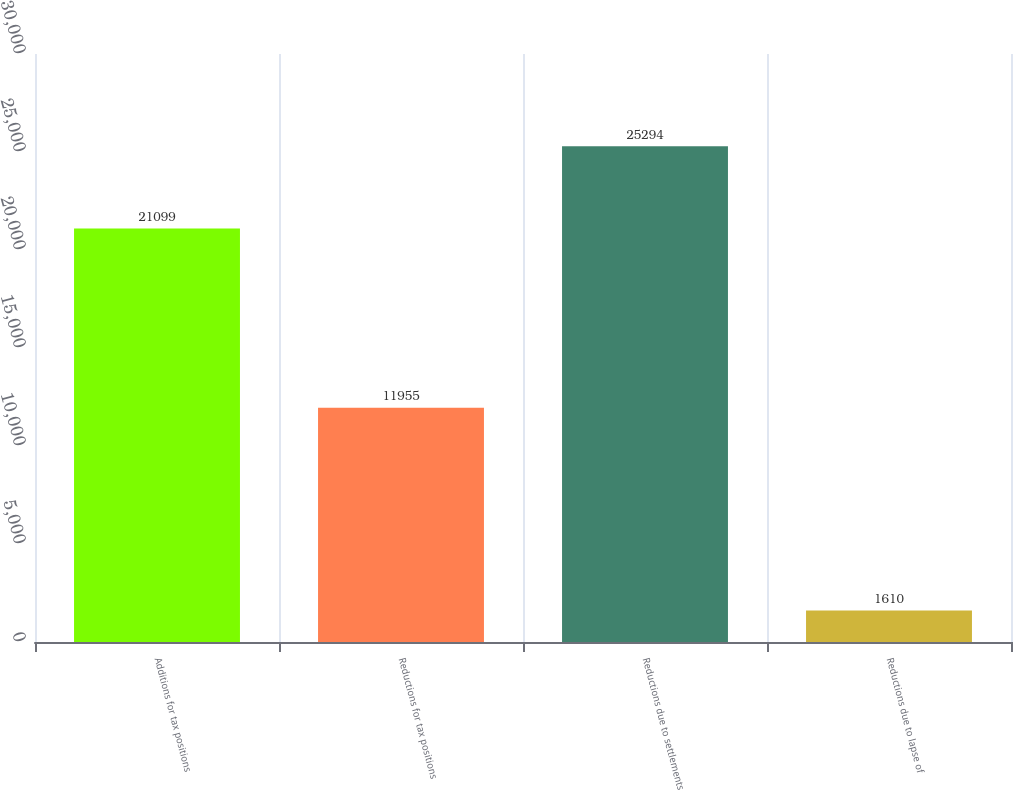Convert chart. <chart><loc_0><loc_0><loc_500><loc_500><bar_chart><fcel>Additions for tax positions<fcel>Reductions for tax positions<fcel>Reductions due to settlements<fcel>Reductions due to lapse of<nl><fcel>21099<fcel>11955<fcel>25294<fcel>1610<nl></chart> 